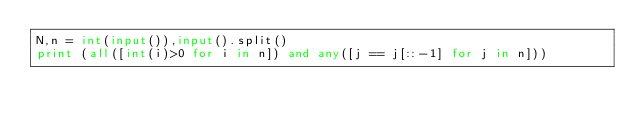Convert code to text. <code><loc_0><loc_0><loc_500><loc_500><_Python_>N,n = int(input()),input().split()
print (all([int(i)>0 for i in n]) and any([j == j[::-1] for j in n]))</code> 